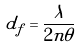Convert formula to latex. <formula><loc_0><loc_0><loc_500><loc_500>d _ { f } = \frac { \lambda } { 2 n \theta }</formula> 